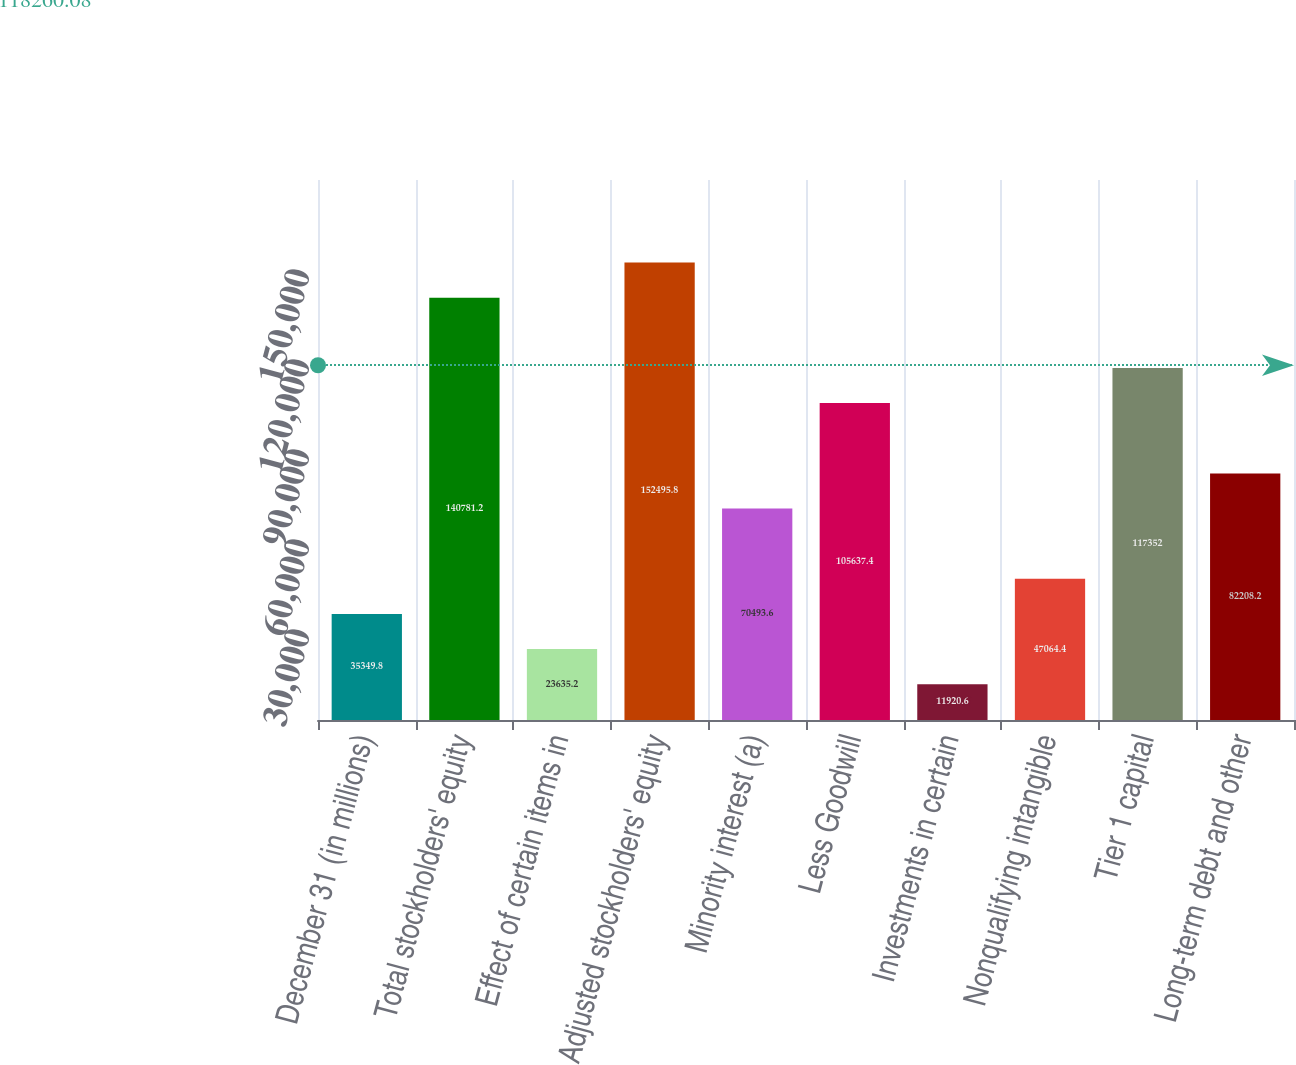Convert chart to OTSL. <chart><loc_0><loc_0><loc_500><loc_500><bar_chart><fcel>December 31 (in millions)<fcel>Total stockholders' equity<fcel>Effect of certain items in<fcel>Adjusted stockholders' equity<fcel>Minority interest (a)<fcel>Less Goodwill<fcel>Investments in certain<fcel>Nonqualifying intangible<fcel>Tier 1 capital<fcel>Long-term debt and other<nl><fcel>35349.8<fcel>140781<fcel>23635.2<fcel>152496<fcel>70493.6<fcel>105637<fcel>11920.6<fcel>47064.4<fcel>117352<fcel>82208.2<nl></chart> 